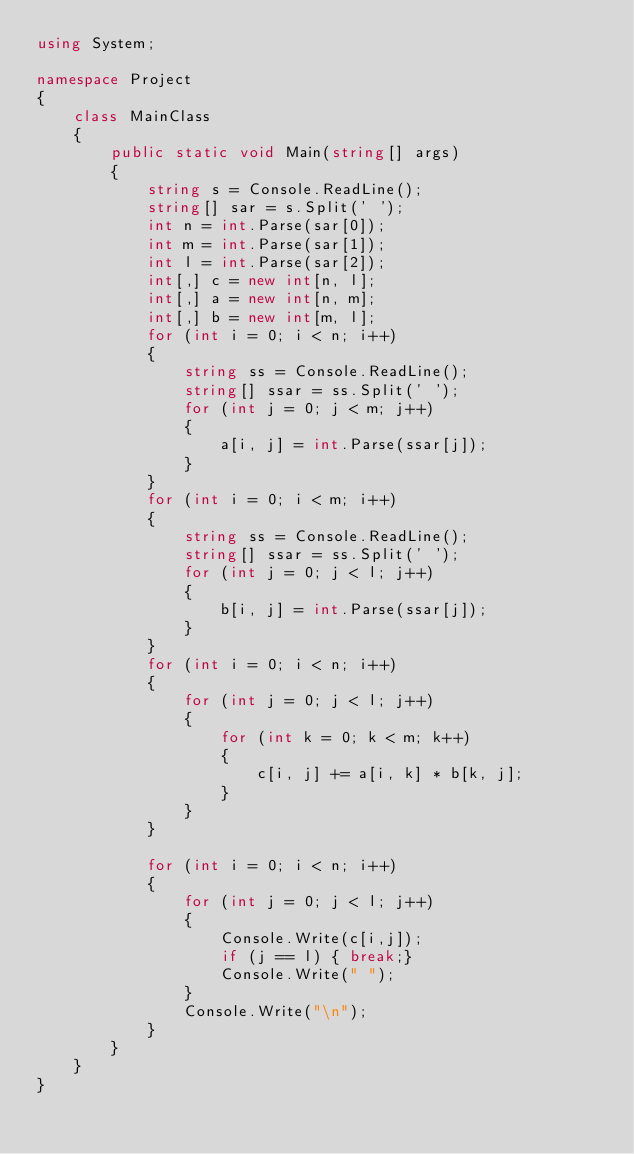<code> <loc_0><loc_0><loc_500><loc_500><_C#_>using System;

namespace Project
{
	class MainClass
	{
		public static void Main(string[] args)
		{
			string s = Console.ReadLine();
			string[] sar = s.Split(' ');
			int n = int.Parse(sar[0]);
			int m = int.Parse(sar[1]);
			int l = int.Parse(sar[2]);
			int[,] c = new int[n, l];
			int[,] a = new int[n, m];
			int[,] b = new int[m, l];
			for (int i = 0; i < n; i++)
			{
				string ss = Console.ReadLine();
				string[] ssar = ss.Split(' ');
				for (int j = 0; j < m; j++)
				{
					a[i, j] = int.Parse(ssar[j]);
				}
			}
			for (int i = 0; i < m; i++)
			{
				string ss = Console.ReadLine();
				string[] ssar = ss.Split(' ');
				for (int j = 0; j < l; j++)
				{
					b[i, j] = int.Parse(ssar[j]);
				}
			}
			for (int i = 0; i < n; i++)
			{
				for (int j = 0; j < l; j++)
				{
					for (int k = 0; k < m; k++)
					{
						c[i, j] += a[i, k] * b[k, j];
					}
				}
			}

			for (int i = 0; i < n; i++)
			{
				for (int j = 0; j < l; j++)
				{
					Console.Write(c[i,j]);
					if (j == l) { break;}
					Console.Write(" ");
				}
				Console.Write("\n");
			}
		}
	}
}</code> 